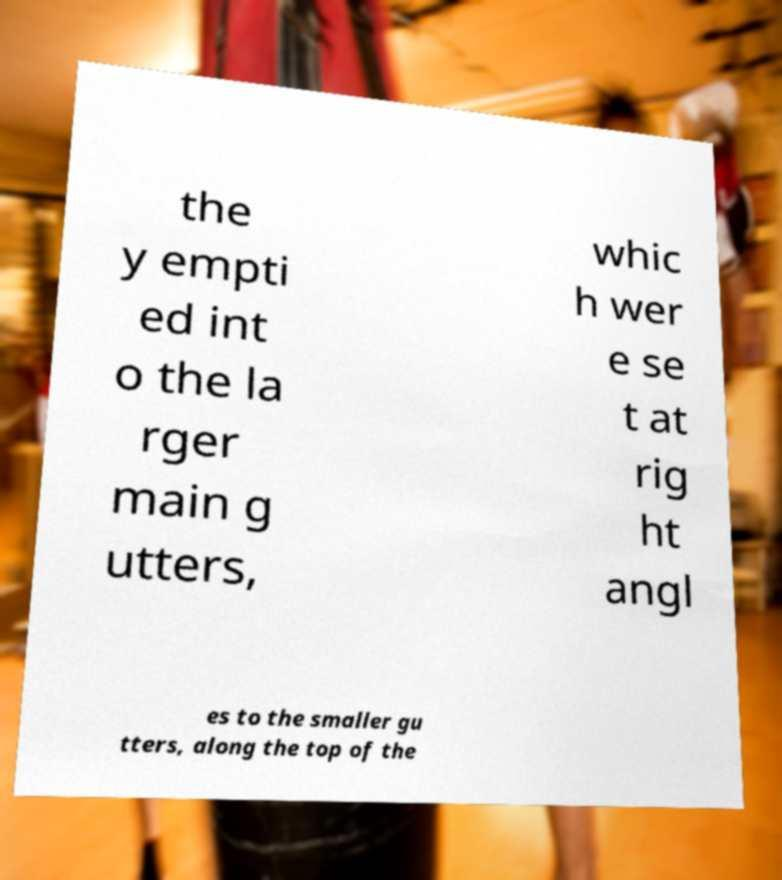Please identify and transcribe the text found in this image. the y empti ed int o the la rger main g utters, whic h wer e se t at rig ht angl es to the smaller gu tters, along the top of the 